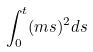<formula> <loc_0><loc_0><loc_500><loc_500>\int _ { 0 } ^ { t } ( m s ) ^ { 2 } d s</formula> 